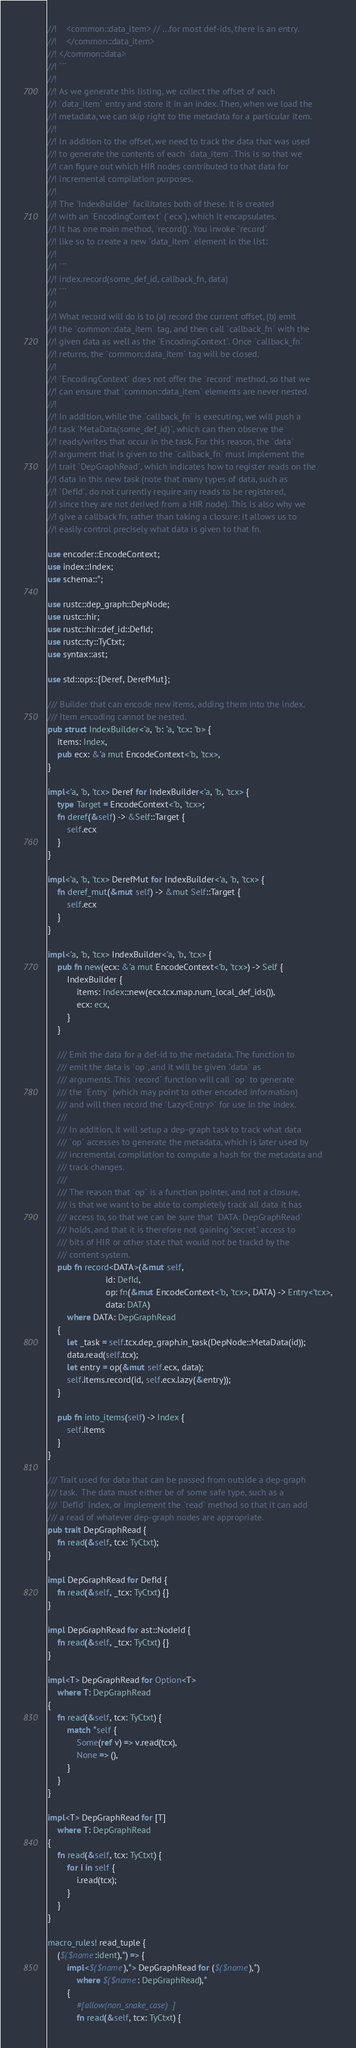<code> <loc_0><loc_0><loc_500><loc_500><_Rust_>//!    <common::data_item> // ...for most def-ids, there is an entry.
//!    </common::data_item>
//! </common::data>
//! ```
//!
//! As we generate this listing, we collect the offset of each
//! `data_item` entry and store it in an index. Then, when we load the
//! metadata, we can skip right to the metadata for a particular item.
//!
//! In addition to the offset, we need to track the data that was used
//! to generate the contents of each `data_item`. This is so that we
//! can figure out which HIR nodes contributed to that data for
//! incremental compilation purposes.
//!
//! The `IndexBuilder` facilitates both of these. It is created
//! with an `EncodingContext` (`ecx`), which it encapsulates.
//! It has one main method, `record()`. You invoke `record`
//! like so to create a new `data_item` element in the list:
//!
//! ```
//! index.record(some_def_id, callback_fn, data)
//! ```
//!
//! What record will do is to (a) record the current offset, (b) emit
//! the `common::data_item` tag, and then call `callback_fn` with the
//! given data as well as the `EncodingContext`. Once `callback_fn`
//! returns, the `common::data_item` tag will be closed.
//!
//! `EncodingContext` does not offer the `record` method, so that we
//! can ensure that `common::data_item` elements are never nested.
//!
//! In addition, while the `callback_fn` is executing, we will push a
//! task `MetaData(some_def_id)`, which can then observe the
//! reads/writes that occur in the task. For this reason, the `data`
//! argument that is given to the `callback_fn` must implement the
//! trait `DepGraphRead`, which indicates how to register reads on the
//! data in this new task (note that many types of data, such as
//! `DefId`, do not currently require any reads to be registered,
//! since they are not derived from a HIR node). This is also why we
//! give a callback fn, rather than taking a closure: it allows us to
//! easily control precisely what data is given to that fn.

use encoder::EncodeContext;
use index::Index;
use schema::*;

use rustc::dep_graph::DepNode;
use rustc::hir;
use rustc::hir::def_id::DefId;
use rustc::ty::TyCtxt;
use syntax::ast;

use std::ops::{Deref, DerefMut};

/// Builder that can encode new items, adding them into the index.
/// Item encoding cannot be nested.
pub struct IndexBuilder<'a, 'b: 'a, 'tcx: 'b> {
    items: Index,
    pub ecx: &'a mut EncodeContext<'b, 'tcx>,
}

impl<'a, 'b, 'tcx> Deref for IndexBuilder<'a, 'b, 'tcx> {
    type Target = EncodeContext<'b, 'tcx>;
    fn deref(&self) -> &Self::Target {
        self.ecx
    }
}

impl<'a, 'b, 'tcx> DerefMut for IndexBuilder<'a, 'b, 'tcx> {
    fn deref_mut(&mut self) -> &mut Self::Target {
        self.ecx
    }
}

impl<'a, 'b, 'tcx> IndexBuilder<'a, 'b, 'tcx> {
    pub fn new(ecx: &'a mut EncodeContext<'b, 'tcx>) -> Self {
        IndexBuilder {
            items: Index::new(ecx.tcx.map.num_local_def_ids()),
            ecx: ecx,
        }
    }

    /// Emit the data for a def-id to the metadata. The function to
    /// emit the data is `op`, and it will be given `data` as
    /// arguments. This `record` function will call `op` to generate
    /// the `Entry` (which may point to other encoded information)
    /// and will then record the `Lazy<Entry>` for use in the index.
    ///
    /// In addition, it will setup a dep-graph task to track what data
    /// `op` accesses to generate the metadata, which is later used by
    /// incremental compilation to compute a hash for the metadata and
    /// track changes.
    ///
    /// The reason that `op` is a function pointer, and not a closure,
    /// is that we want to be able to completely track all data it has
    /// access to, so that we can be sure that `DATA: DepGraphRead`
    /// holds, and that it is therefore not gaining "secret" access to
    /// bits of HIR or other state that would not be trackd by the
    /// content system.
    pub fn record<DATA>(&mut self,
                        id: DefId,
                        op: fn(&mut EncodeContext<'b, 'tcx>, DATA) -> Entry<'tcx>,
                        data: DATA)
        where DATA: DepGraphRead
    {
        let _task = self.tcx.dep_graph.in_task(DepNode::MetaData(id));
        data.read(self.tcx);
        let entry = op(&mut self.ecx, data);
        self.items.record(id, self.ecx.lazy(&entry));
    }

    pub fn into_items(self) -> Index {
        self.items
    }
}

/// Trait used for data that can be passed from outside a dep-graph
/// task.  The data must either be of some safe type, such as a
/// `DefId` index, or implement the `read` method so that it can add
/// a read of whatever dep-graph nodes are appropriate.
pub trait DepGraphRead {
    fn read(&self, tcx: TyCtxt);
}

impl DepGraphRead for DefId {
    fn read(&self, _tcx: TyCtxt) {}
}

impl DepGraphRead for ast::NodeId {
    fn read(&self, _tcx: TyCtxt) {}
}

impl<T> DepGraphRead for Option<T>
    where T: DepGraphRead
{
    fn read(&self, tcx: TyCtxt) {
        match *self {
            Some(ref v) => v.read(tcx),
            None => (),
        }
    }
}

impl<T> DepGraphRead for [T]
    where T: DepGraphRead
{
    fn read(&self, tcx: TyCtxt) {
        for i in self {
            i.read(tcx);
        }
    }
}

macro_rules! read_tuple {
    ($($name:ident),*) => {
        impl<$($name),*> DepGraphRead for ($($name),*)
            where $($name: DepGraphRead),*
        {
            #[allow(non_snake_case)]
            fn read(&self, tcx: TyCtxt) {</code> 